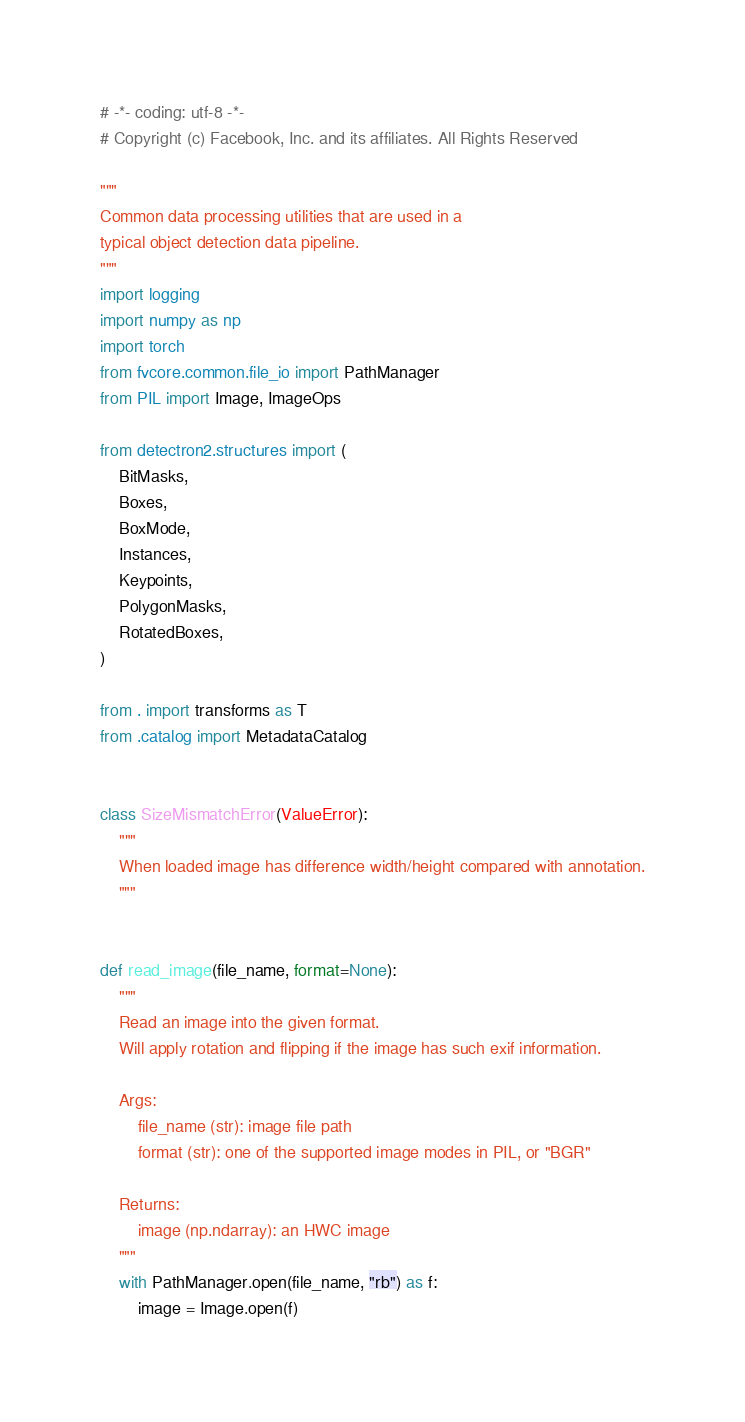Convert code to text. <code><loc_0><loc_0><loc_500><loc_500><_Python_># -*- coding: utf-8 -*-
# Copyright (c) Facebook, Inc. and its affiliates. All Rights Reserved

"""
Common data processing utilities that are used in a
typical object detection data pipeline.
"""
import logging
import numpy as np
import torch
from fvcore.common.file_io import PathManager
from PIL import Image, ImageOps

from detectron2.structures import (
    BitMasks,
    Boxes,
    BoxMode,
    Instances,
    Keypoints,
    PolygonMasks,
    RotatedBoxes,
)

from . import transforms as T
from .catalog import MetadataCatalog


class SizeMismatchError(ValueError):
    """
    When loaded image has difference width/height compared with annotation.
    """


def read_image(file_name, format=None):
    """
    Read an image into the given format.
    Will apply rotation and flipping if the image has such exif information.

    Args:
        file_name (str): image file path
        format (str): one of the supported image modes in PIL, or "BGR"

    Returns:
        image (np.ndarray): an HWC image
    """
    with PathManager.open(file_name, "rb") as f:
        image = Image.open(f)
</code> 